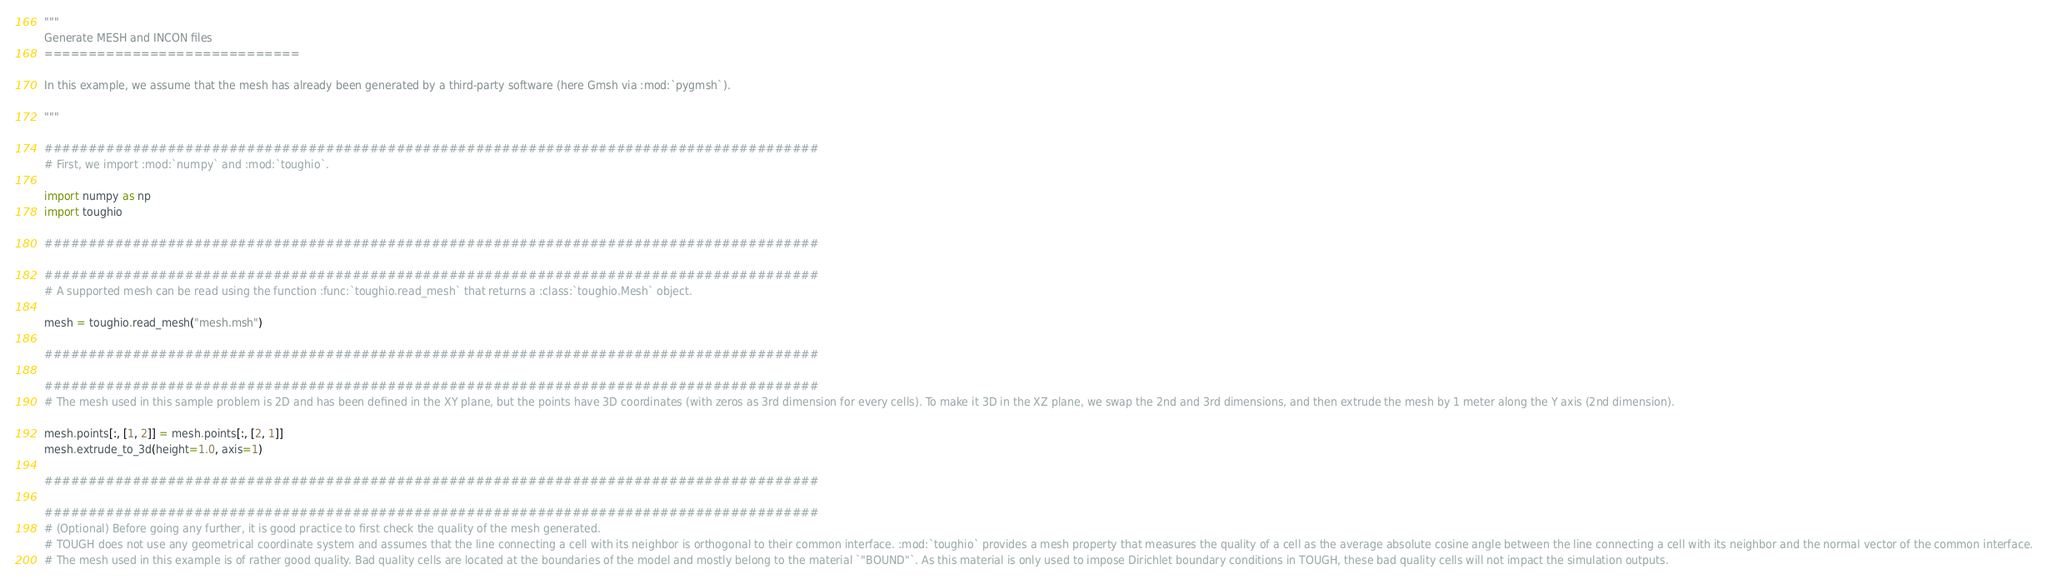Convert code to text. <code><loc_0><loc_0><loc_500><loc_500><_Python_>"""
Generate MESH and INCON files
=============================

In this example, we assume that the mesh has already been generated by a third-party software (here Gmsh via :mod:`pygmsh`).

"""

########################################################################################
# First, we import :mod:`numpy` and :mod:`toughio`.

import numpy as np
import toughio

########################################################################################

########################################################################################
# A supported mesh can be read using the function :func:`toughio.read_mesh` that returns a :class:`toughio.Mesh` object.

mesh = toughio.read_mesh("mesh.msh")

########################################################################################

########################################################################################
# The mesh used in this sample problem is 2D and has been defined in the XY plane, but the points have 3D coordinates (with zeros as 3rd dimension for every cells). To make it 3D in the XZ plane, we swap the 2nd and 3rd dimensions, and then extrude the mesh by 1 meter along the Y axis (2nd dimension).

mesh.points[:, [1, 2]] = mesh.points[:, [2, 1]]
mesh.extrude_to_3d(height=1.0, axis=1)

########################################################################################

########################################################################################
# (Optional) Before going any further, it is good practice to first check the quality of the mesh generated.
# TOUGH does not use any geometrical coordinate system and assumes that the line connecting a cell with its neighbor is orthogonal to their common interface. :mod:`toughio` provides a mesh property that measures the quality of a cell as the average absolute cosine angle between the line connecting a cell with its neighbor and the normal vector of the common interface.
# The mesh used in this example is of rather good quality. Bad quality cells are located at the boundaries of the model and mostly belong to the material `"BOUND"`. As this material is only used to impose Dirichlet boundary conditions in TOUGH, these bad quality cells will not impact the simulation outputs.
</code> 